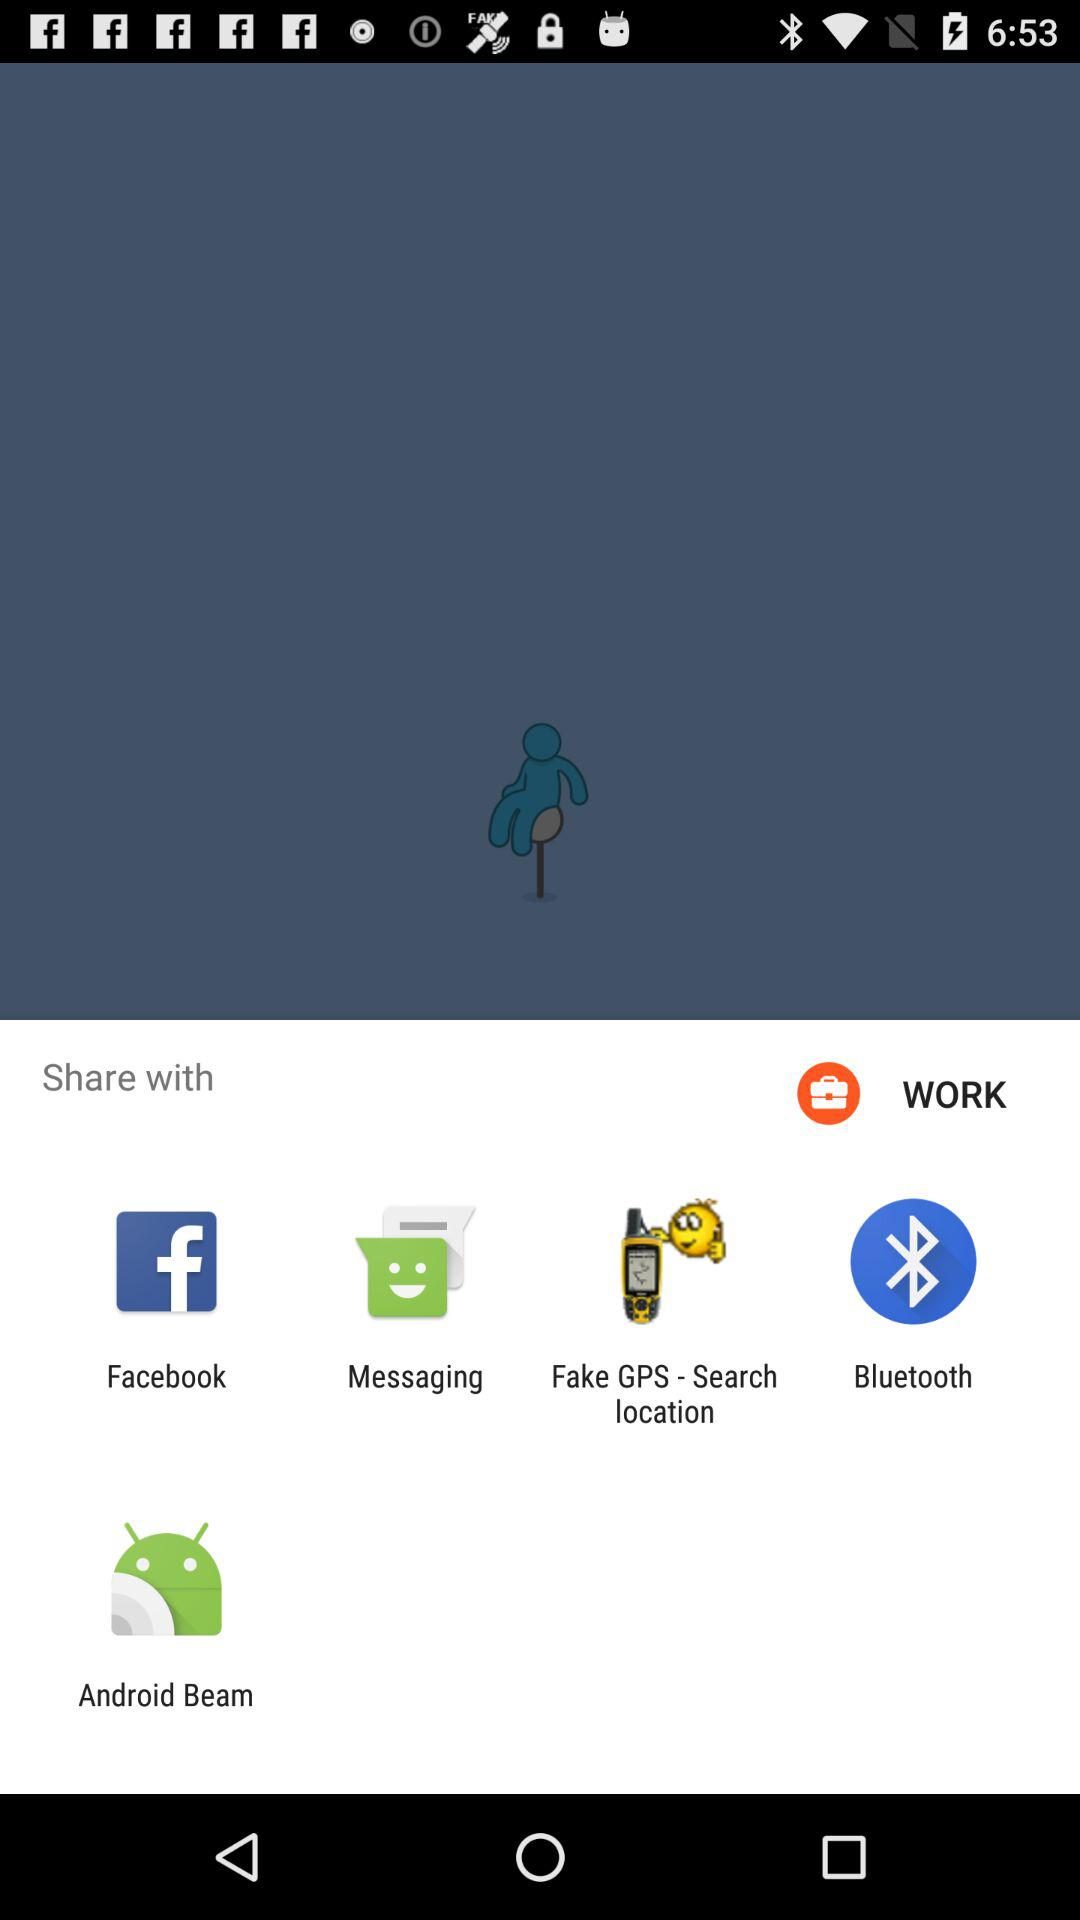Which applications can be used for sharing? The applications that can be used for sharing are "Facebook", "Messaging", "Fake GPS - Search location", "Bluetooth" and "Android Beam". 